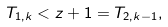Convert formula to latex. <formula><loc_0><loc_0><loc_500><loc_500>T _ { 1 , k } < z + 1 = T _ { 2 , k - 1 } ,</formula> 